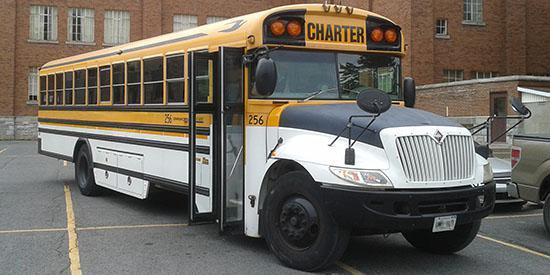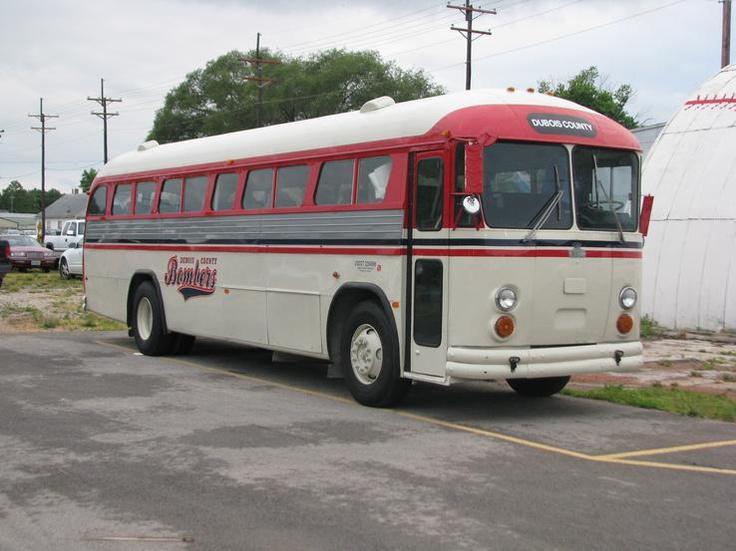The first image is the image on the left, the second image is the image on the right. Analyze the images presented: Is the assertion "In at least one image there is a white bus with a flat front hood facing forward right." valid? Answer yes or no. Yes. 